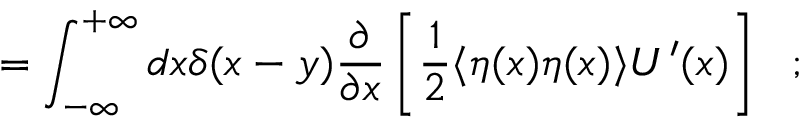Convert formula to latex. <formula><loc_0><loc_0><loc_500><loc_500>= \int _ { - \infty } ^ { + \infty } d x \delta ( x - y ) \frac { \partial } { \partial x } \left [ \frac { 1 } { 2 } \langle \eta ( x ) \eta ( x ) \rangle U ^ { \prime } ( x ) \right ] \ \ ;</formula> 